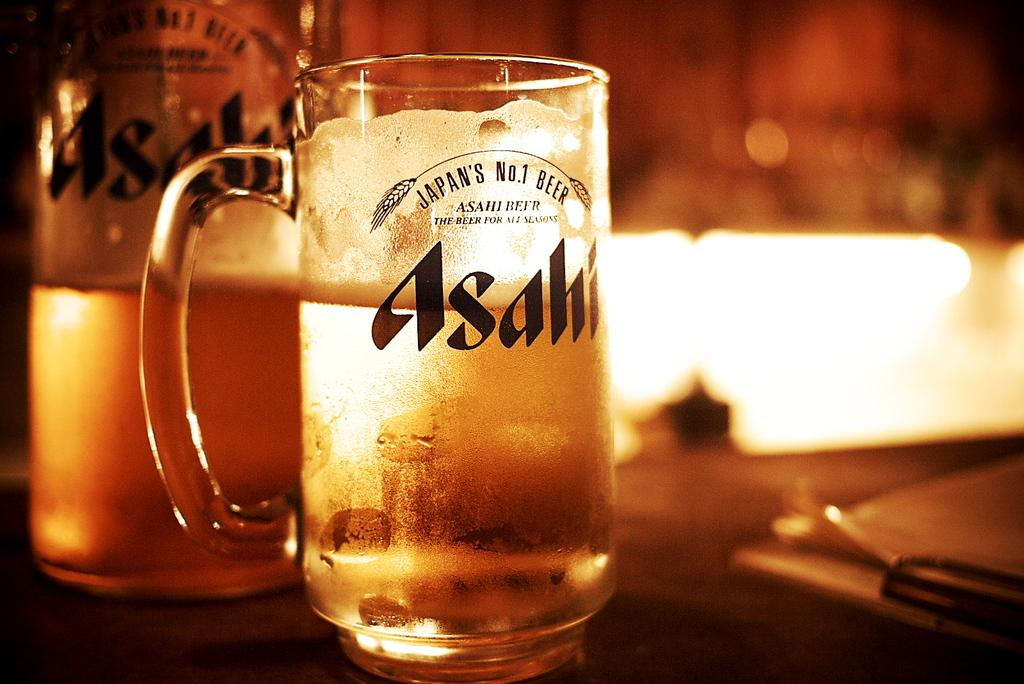<image>
Offer a succinct explanation of the picture presented. A glass and a bottle of Asahi beer are on the table. 